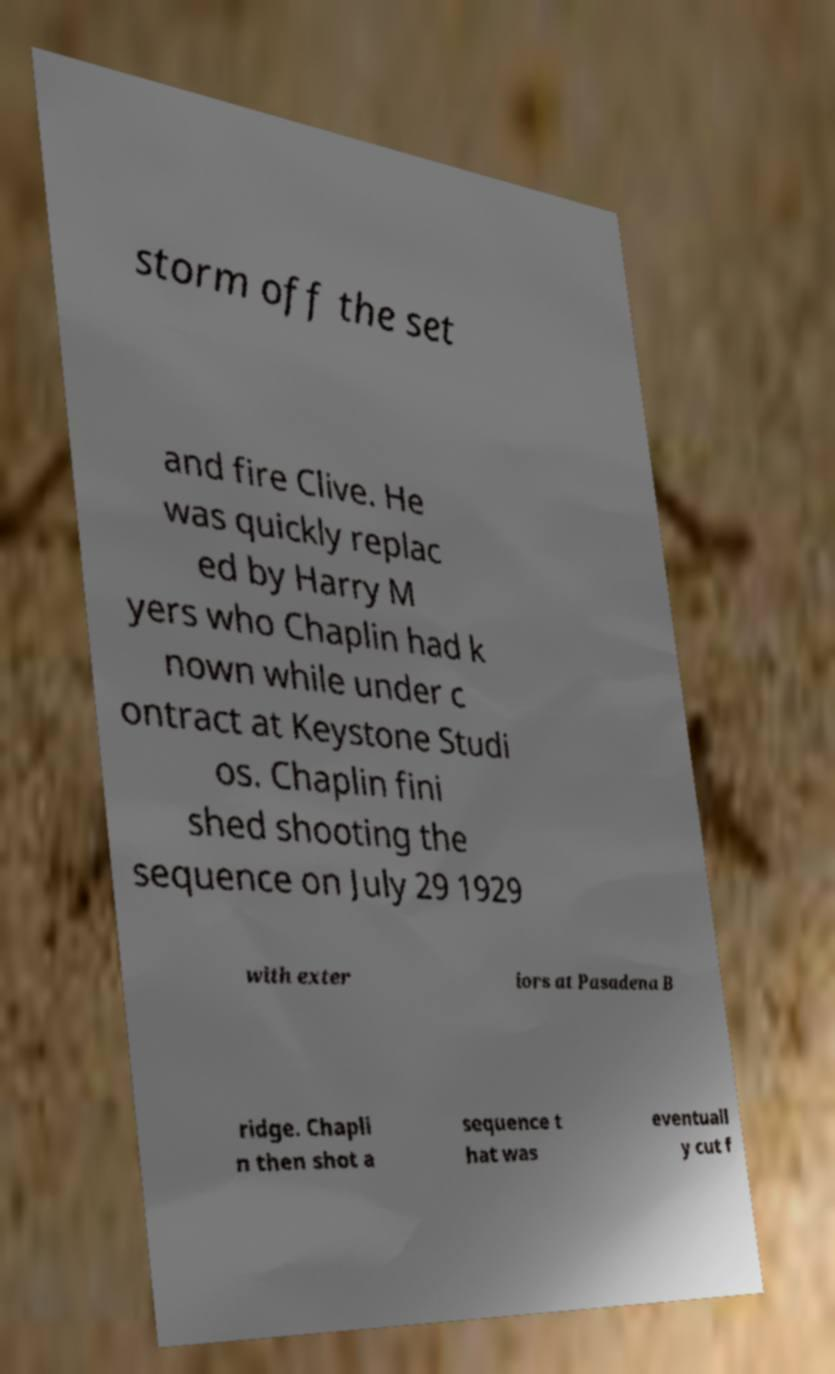I need the written content from this picture converted into text. Can you do that? storm off the set and fire Clive. He was quickly replac ed by Harry M yers who Chaplin had k nown while under c ontract at Keystone Studi os. Chaplin fini shed shooting the sequence on July 29 1929 with exter iors at Pasadena B ridge. Chapli n then shot a sequence t hat was eventuall y cut f 